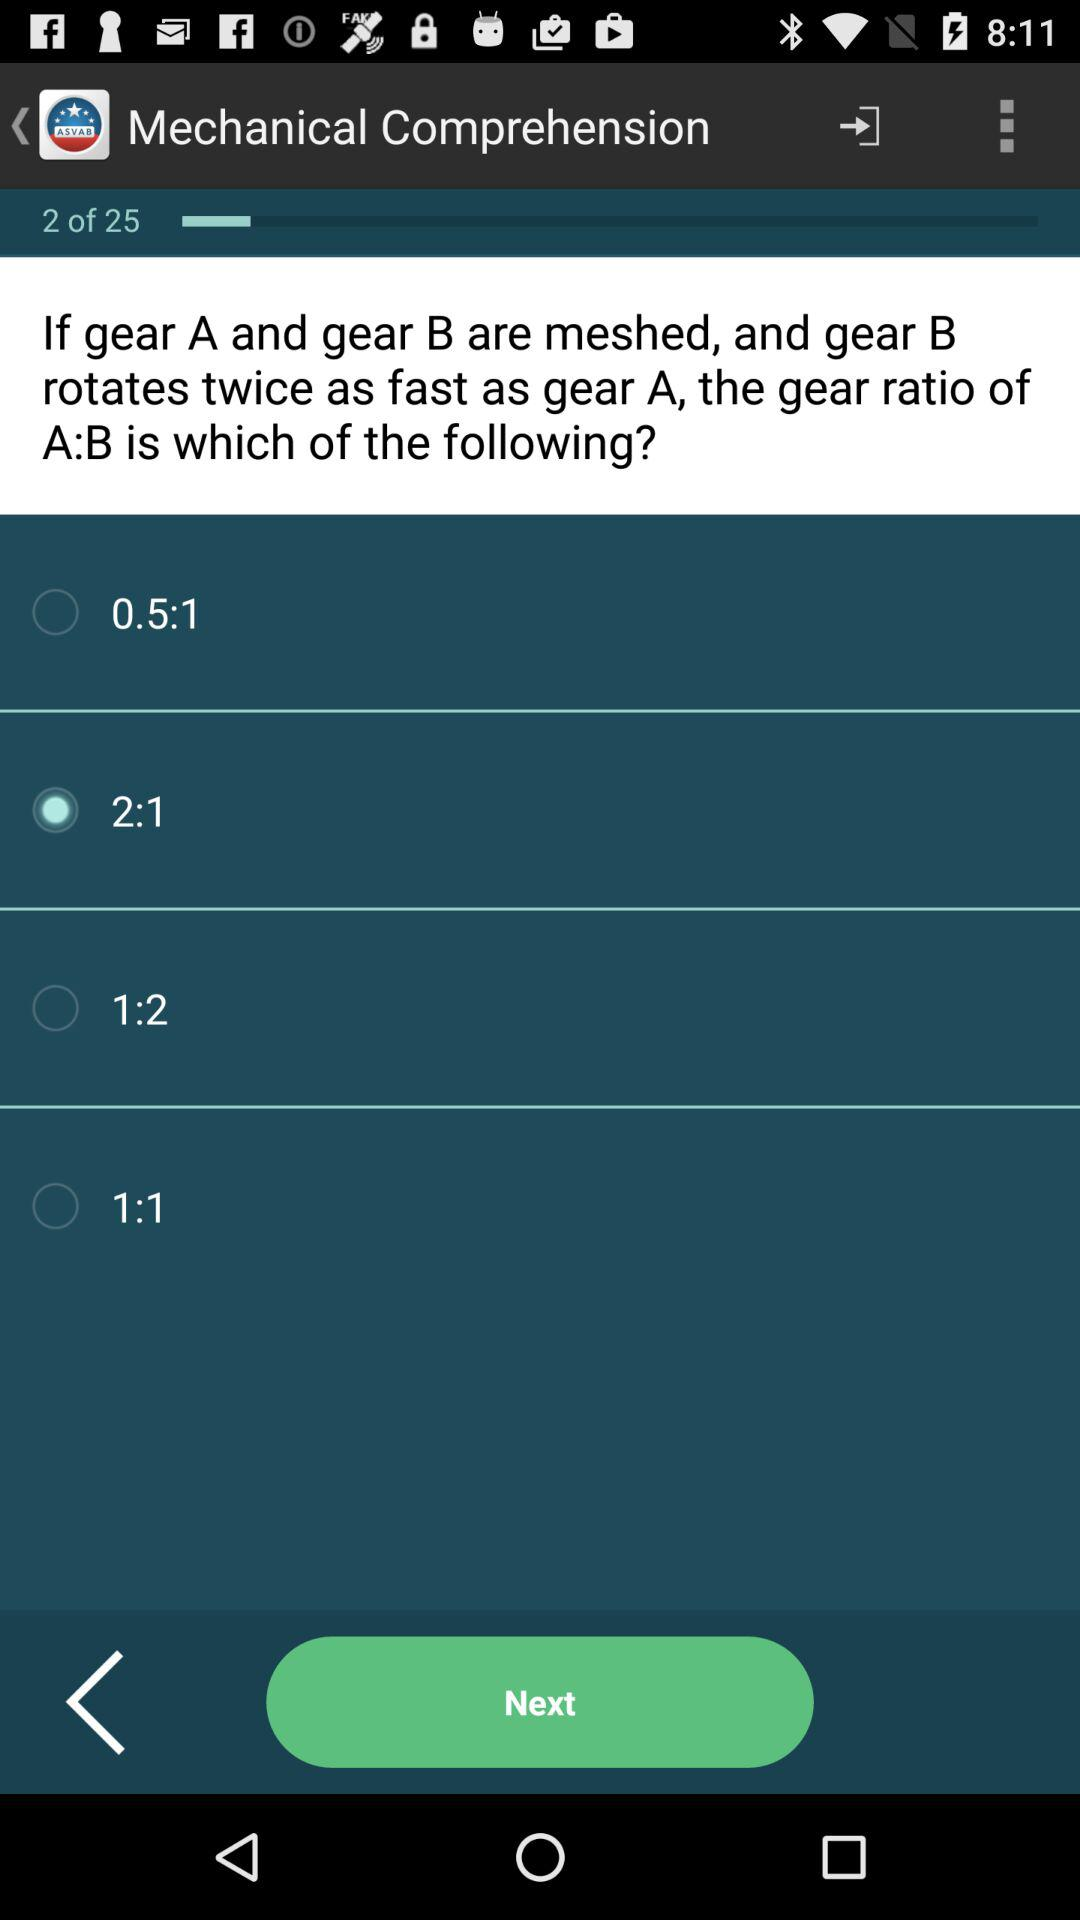How many options are there for gear ratio of A:B?
Answer the question using a single word or phrase. 4 